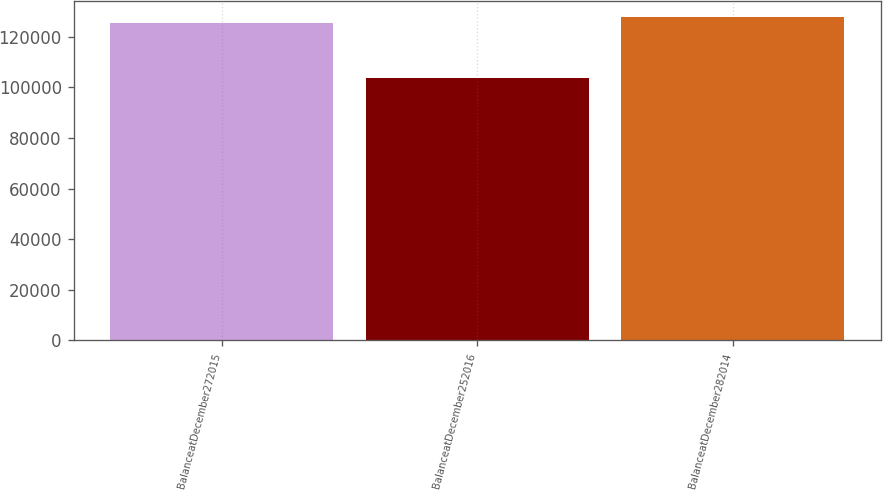Convert chart to OTSL. <chart><loc_0><loc_0><loc_500><loc_500><bar_chart><fcel>BalanceatDecember272015<fcel>BalanceatDecember252016<fcel>BalanceatDecember282014<nl><fcel>125607<fcel>103744<fcel>127793<nl></chart> 